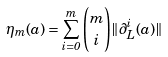Convert formula to latex. <formula><loc_0><loc_0><loc_500><loc_500>\eta _ { m } ( a ) = \sum _ { i = 0 } ^ { m } \binom { m } { i } \| \partial _ { L } ^ { i } ( a ) \|</formula> 